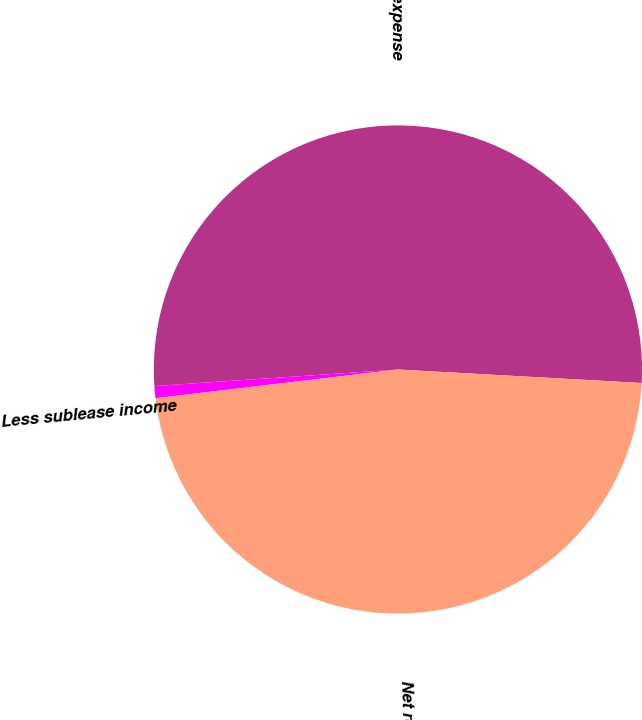Convert chart. <chart><loc_0><loc_0><loc_500><loc_500><pie_chart><fcel>Gross rental expense<fcel>Less sublease income<fcel>Net rental expense<nl><fcel>51.96%<fcel>0.8%<fcel>47.24%<nl></chart> 